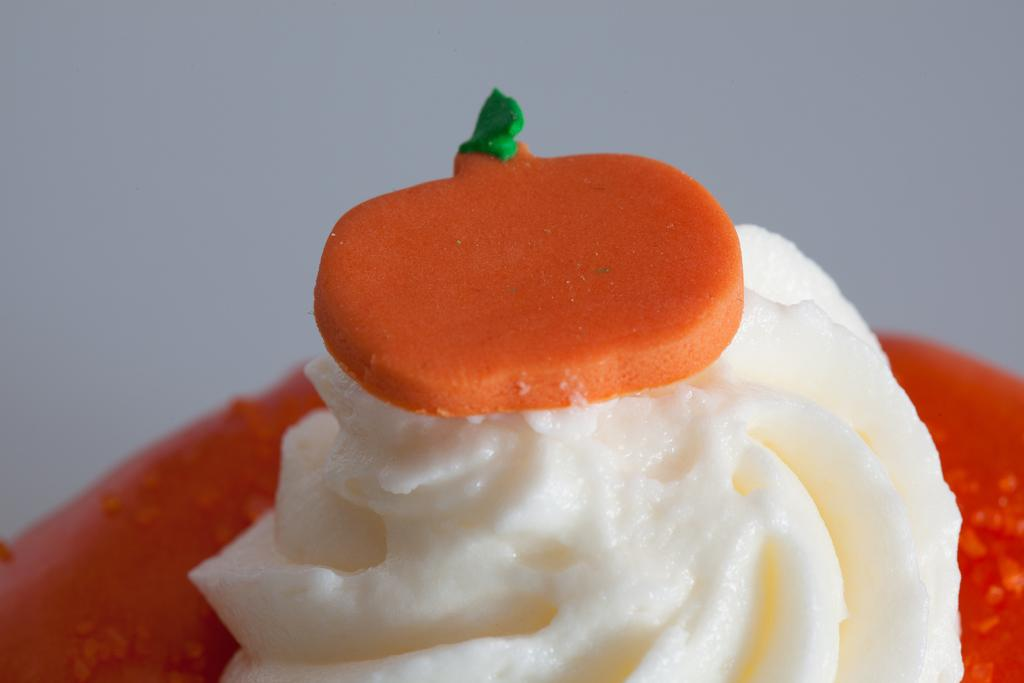What is on the plate in the image? There is an ice cream on the plate. What is on top of the ice cream? There is a topping on the ice cream. What type of ink can be seen on the ice cream in the image? There is no ink present on the ice cream in the image. Can you describe the waves in the background of the image? There are no waves visible in the image; it only features a plate with ice cream and a topping. 